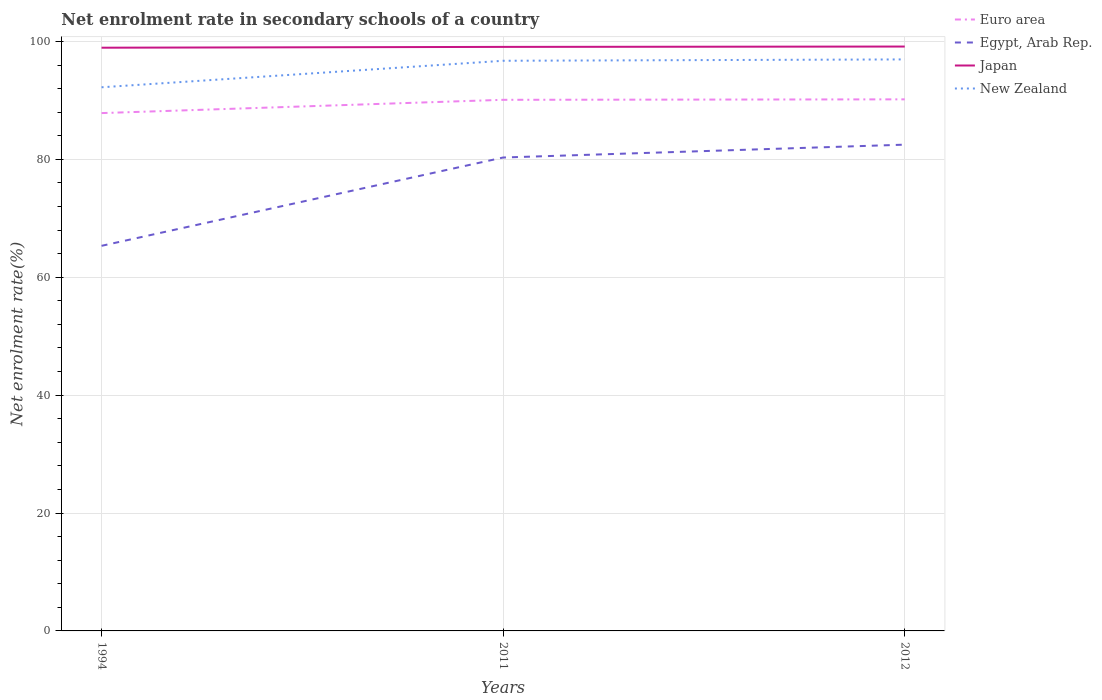Does the line corresponding to New Zealand intersect with the line corresponding to Euro area?
Keep it short and to the point. No. Across all years, what is the maximum net enrolment rate in secondary schools in Egypt, Arab Rep.?
Make the answer very short. 65.33. What is the total net enrolment rate in secondary schools in Euro area in the graph?
Offer a terse response. -2.33. What is the difference between the highest and the second highest net enrolment rate in secondary schools in Egypt, Arab Rep.?
Keep it short and to the point. 17.16. Is the net enrolment rate in secondary schools in Euro area strictly greater than the net enrolment rate in secondary schools in Egypt, Arab Rep. over the years?
Offer a terse response. No. How many lines are there?
Give a very brief answer. 4. How many years are there in the graph?
Ensure brevity in your answer.  3. Are the values on the major ticks of Y-axis written in scientific E-notation?
Provide a succinct answer. No. Does the graph contain any zero values?
Offer a terse response. No. Where does the legend appear in the graph?
Offer a terse response. Top right. How many legend labels are there?
Your answer should be compact. 4. What is the title of the graph?
Your answer should be compact. Net enrolment rate in secondary schools of a country. What is the label or title of the X-axis?
Provide a succinct answer. Years. What is the label or title of the Y-axis?
Your answer should be very brief. Net enrolment rate(%). What is the Net enrolment rate(%) in Euro area in 1994?
Your answer should be compact. 87.85. What is the Net enrolment rate(%) of Egypt, Arab Rep. in 1994?
Offer a terse response. 65.33. What is the Net enrolment rate(%) of Japan in 1994?
Your answer should be very brief. 98.94. What is the Net enrolment rate(%) of New Zealand in 1994?
Keep it short and to the point. 92.23. What is the Net enrolment rate(%) in Euro area in 2011?
Offer a terse response. 90.1. What is the Net enrolment rate(%) of Egypt, Arab Rep. in 2011?
Make the answer very short. 80.32. What is the Net enrolment rate(%) of Japan in 2011?
Provide a short and direct response. 99.08. What is the Net enrolment rate(%) of New Zealand in 2011?
Offer a very short reply. 96.73. What is the Net enrolment rate(%) in Euro area in 2012?
Provide a succinct answer. 90.18. What is the Net enrolment rate(%) of Egypt, Arab Rep. in 2012?
Your answer should be very brief. 82.5. What is the Net enrolment rate(%) in Japan in 2012?
Ensure brevity in your answer.  99.14. What is the Net enrolment rate(%) in New Zealand in 2012?
Your answer should be compact. 96.96. Across all years, what is the maximum Net enrolment rate(%) in Euro area?
Provide a succinct answer. 90.18. Across all years, what is the maximum Net enrolment rate(%) in Egypt, Arab Rep.?
Offer a very short reply. 82.5. Across all years, what is the maximum Net enrolment rate(%) of Japan?
Offer a terse response. 99.14. Across all years, what is the maximum Net enrolment rate(%) of New Zealand?
Make the answer very short. 96.96. Across all years, what is the minimum Net enrolment rate(%) in Euro area?
Your answer should be compact. 87.85. Across all years, what is the minimum Net enrolment rate(%) in Egypt, Arab Rep.?
Offer a very short reply. 65.33. Across all years, what is the minimum Net enrolment rate(%) of Japan?
Your response must be concise. 98.94. Across all years, what is the minimum Net enrolment rate(%) in New Zealand?
Give a very brief answer. 92.23. What is the total Net enrolment rate(%) in Euro area in the graph?
Keep it short and to the point. 268.14. What is the total Net enrolment rate(%) of Egypt, Arab Rep. in the graph?
Your response must be concise. 228.15. What is the total Net enrolment rate(%) in Japan in the graph?
Your response must be concise. 297.17. What is the total Net enrolment rate(%) of New Zealand in the graph?
Provide a succinct answer. 285.92. What is the difference between the Net enrolment rate(%) of Euro area in 1994 and that in 2011?
Ensure brevity in your answer.  -2.25. What is the difference between the Net enrolment rate(%) of Egypt, Arab Rep. in 1994 and that in 2011?
Your answer should be very brief. -14.98. What is the difference between the Net enrolment rate(%) of Japan in 1994 and that in 2011?
Ensure brevity in your answer.  -0.14. What is the difference between the Net enrolment rate(%) in New Zealand in 1994 and that in 2011?
Offer a very short reply. -4.5. What is the difference between the Net enrolment rate(%) of Euro area in 1994 and that in 2012?
Offer a very short reply. -2.33. What is the difference between the Net enrolment rate(%) in Egypt, Arab Rep. in 1994 and that in 2012?
Offer a terse response. -17.16. What is the difference between the Net enrolment rate(%) of Japan in 1994 and that in 2012?
Offer a terse response. -0.2. What is the difference between the Net enrolment rate(%) of New Zealand in 1994 and that in 2012?
Provide a short and direct response. -4.73. What is the difference between the Net enrolment rate(%) in Euro area in 2011 and that in 2012?
Ensure brevity in your answer.  -0.08. What is the difference between the Net enrolment rate(%) of Egypt, Arab Rep. in 2011 and that in 2012?
Offer a very short reply. -2.18. What is the difference between the Net enrolment rate(%) of Japan in 2011 and that in 2012?
Offer a terse response. -0.06. What is the difference between the Net enrolment rate(%) of New Zealand in 2011 and that in 2012?
Ensure brevity in your answer.  -0.23. What is the difference between the Net enrolment rate(%) in Euro area in 1994 and the Net enrolment rate(%) in Egypt, Arab Rep. in 2011?
Offer a very short reply. 7.54. What is the difference between the Net enrolment rate(%) in Euro area in 1994 and the Net enrolment rate(%) in Japan in 2011?
Your answer should be compact. -11.23. What is the difference between the Net enrolment rate(%) in Euro area in 1994 and the Net enrolment rate(%) in New Zealand in 2011?
Offer a terse response. -8.88. What is the difference between the Net enrolment rate(%) of Egypt, Arab Rep. in 1994 and the Net enrolment rate(%) of Japan in 2011?
Keep it short and to the point. -33.75. What is the difference between the Net enrolment rate(%) in Egypt, Arab Rep. in 1994 and the Net enrolment rate(%) in New Zealand in 2011?
Your answer should be compact. -31.39. What is the difference between the Net enrolment rate(%) in Japan in 1994 and the Net enrolment rate(%) in New Zealand in 2011?
Keep it short and to the point. 2.22. What is the difference between the Net enrolment rate(%) in Euro area in 1994 and the Net enrolment rate(%) in Egypt, Arab Rep. in 2012?
Give a very brief answer. 5.35. What is the difference between the Net enrolment rate(%) of Euro area in 1994 and the Net enrolment rate(%) of Japan in 2012?
Make the answer very short. -11.29. What is the difference between the Net enrolment rate(%) in Euro area in 1994 and the Net enrolment rate(%) in New Zealand in 2012?
Your response must be concise. -9.11. What is the difference between the Net enrolment rate(%) in Egypt, Arab Rep. in 1994 and the Net enrolment rate(%) in Japan in 2012?
Keep it short and to the point. -33.81. What is the difference between the Net enrolment rate(%) in Egypt, Arab Rep. in 1994 and the Net enrolment rate(%) in New Zealand in 2012?
Provide a short and direct response. -31.63. What is the difference between the Net enrolment rate(%) of Japan in 1994 and the Net enrolment rate(%) of New Zealand in 2012?
Your answer should be very brief. 1.99. What is the difference between the Net enrolment rate(%) of Euro area in 2011 and the Net enrolment rate(%) of Egypt, Arab Rep. in 2012?
Give a very brief answer. 7.61. What is the difference between the Net enrolment rate(%) in Euro area in 2011 and the Net enrolment rate(%) in Japan in 2012?
Your answer should be very brief. -9.04. What is the difference between the Net enrolment rate(%) in Euro area in 2011 and the Net enrolment rate(%) in New Zealand in 2012?
Your response must be concise. -6.85. What is the difference between the Net enrolment rate(%) of Egypt, Arab Rep. in 2011 and the Net enrolment rate(%) of Japan in 2012?
Make the answer very short. -18.83. What is the difference between the Net enrolment rate(%) of Egypt, Arab Rep. in 2011 and the Net enrolment rate(%) of New Zealand in 2012?
Provide a succinct answer. -16.64. What is the difference between the Net enrolment rate(%) in Japan in 2011 and the Net enrolment rate(%) in New Zealand in 2012?
Offer a terse response. 2.12. What is the average Net enrolment rate(%) in Euro area per year?
Offer a very short reply. 89.38. What is the average Net enrolment rate(%) of Egypt, Arab Rep. per year?
Ensure brevity in your answer.  76.05. What is the average Net enrolment rate(%) of Japan per year?
Your answer should be compact. 99.06. What is the average Net enrolment rate(%) in New Zealand per year?
Provide a short and direct response. 95.31. In the year 1994, what is the difference between the Net enrolment rate(%) of Euro area and Net enrolment rate(%) of Egypt, Arab Rep.?
Offer a terse response. 22.52. In the year 1994, what is the difference between the Net enrolment rate(%) of Euro area and Net enrolment rate(%) of Japan?
Ensure brevity in your answer.  -11.09. In the year 1994, what is the difference between the Net enrolment rate(%) of Euro area and Net enrolment rate(%) of New Zealand?
Offer a very short reply. -4.38. In the year 1994, what is the difference between the Net enrolment rate(%) in Egypt, Arab Rep. and Net enrolment rate(%) in Japan?
Your response must be concise. -33.61. In the year 1994, what is the difference between the Net enrolment rate(%) of Egypt, Arab Rep. and Net enrolment rate(%) of New Zealand?
Provide a succinct answer. -26.9. In the year 1994, what is the difference between the Net enrolment rate(%) in Japan and Net enrolment rate(%) in New Zealand?
Provide a short and direct response. 6.71. In the year 2011, what is the difference between the Net enrolment rate(%) in Euro area and Net enrolment rate(%) in Egypt, Arab Rep.?
Give a very brief answer. 9.79. In the year 2011, what is the difference between the Net enrolment rate(%) in Euro area and Net enrolment rate(%) in Japan?
Ensure brevity in your answer.  -8.98. In the year 2011, what is the difference between the Net enrolment rate(%) in Euro area and Net enrolment rate(%) in New Zealand?
Your answer should be compact. -6.62. In the year 2011, what is the difference between the Net enrolment rate(%) of Egypt, Arab Rep. and Net enrolment rate(%) of Japan?
Ensure brevity in your answer.  -18.77. In the year 2011, what is the difference between the Net enrolment rate(%) in Egypt, Arab Rep. and Net enrolment rate(%) in New Zealand?
Make the answer very short. -16.41. In the year 2011, what is the difference between the Net enrolment rate(%) of Japan and Net enrolment rate(%) of New Zealand?
Your response must be concise. 2.36. In the year 2012, what is the difference between the Net enrolment rate(%) in Euro area and Net enrolment rate(%) in Egypt, Arab Rep.?
Give a very brief answer. 7.69. In the year 2012, what is the difference between the Net enrolment rate(%) in Euro area and Net enrolment rate(%) in Japan?
Ensure brevity in your answer.  -8.96. In the year 2012, what is the difference between the Net enrolment rate(%) of Euro area and Net enrolment rate(%) of New Zealand?
Your answer should be compact. -6.78. In the year 2012, what is the difference between the Net enrolment rate(%) in Egypt, Arab Rep. and Net enrolment rate(%) in Japan?
Make the answer very short. -16.65. In the year 2012, what is the difference between the Net enrolment rate(%) of Egypt, Arab Rep. and Net enrolment rate(%) of New Zealand?
Give a very brief answer. -14.46. In the year 2012, what is the difference between the Net enrolment rate(%) in Japan and Net enrolment rate(%) in New Zealand?
Ensure brevity in your answer.  2.18. What is the ratio of the Net enrolment rate(%) of Euro area in 1994 to that in 2011?
Provide a succinct answer. 0.97. What is the ratio of the Net enrolment rate(%) of Egypt, Arab Rep. in 1994 to that in 2011?
Offer a terse response. 0.81. What is the ratio of the Net enrolment rate(%) of Japan in 1994 to that in 2011?
Make the answer very short. 1. What is the ratio of the Net enrolment rate(%) in New Zealand in 1994 to that in 2011?
Ensure brevity in your answer.  0.95. What is the ratio of the Net enrolment rate(%) in Euro area in 1994 to that in 2012?
Your response must be concise. 0.97. What is the ratio of the Net enrolment rate(%) in Egypt, Arab Rep. in 1994 to that in 2012?
Make the answer very short. 0.79. What is the ratio of the Net enrolment rate(%) in New Zealand in 1994 to that in 2012?
Offer a terse response. 0.95. What is the ratio of the Net enrolment rate(%) of Egypt, Arab Rep. in 2011 to that in 2012?
Your answer should be compact. 0.97. What is the difference between the highest and the second highest Net enrolment rate(%) of Euro area?
Offer a very short reply. 0.08. What is the difference between the highest and the second highest Net enrolment rate(%) in Egypt, Arab Rep.?
Offer a very short reply. 2.18. What is the difference between the highest and the second highest Net enrolment rate(%) of Japan?
Make the answer very short. 0.06. What is the difference between the highest and the second highest Net enrolment rate(%) in New Zealand?
Provide a succinct answer. 0.23. What is the difference between the highest and the lowest Net enrolment rate(%) in Euro area?
Your answer should be compact. 2.33. What is the difference between the highest and the lowest Net enrolment rate(%) of Egypt, Arab Rep.?
Provide a succinct answer. 17.16. What is the difference between the highest and the lowest Net enrolment rate(%) in Japan?
Give a very brief answer. 0.2. What is the difference between the highest and the lowest Net enrolment rate(%) in New Zealand?
Keep it short and to the point. 4.73. 